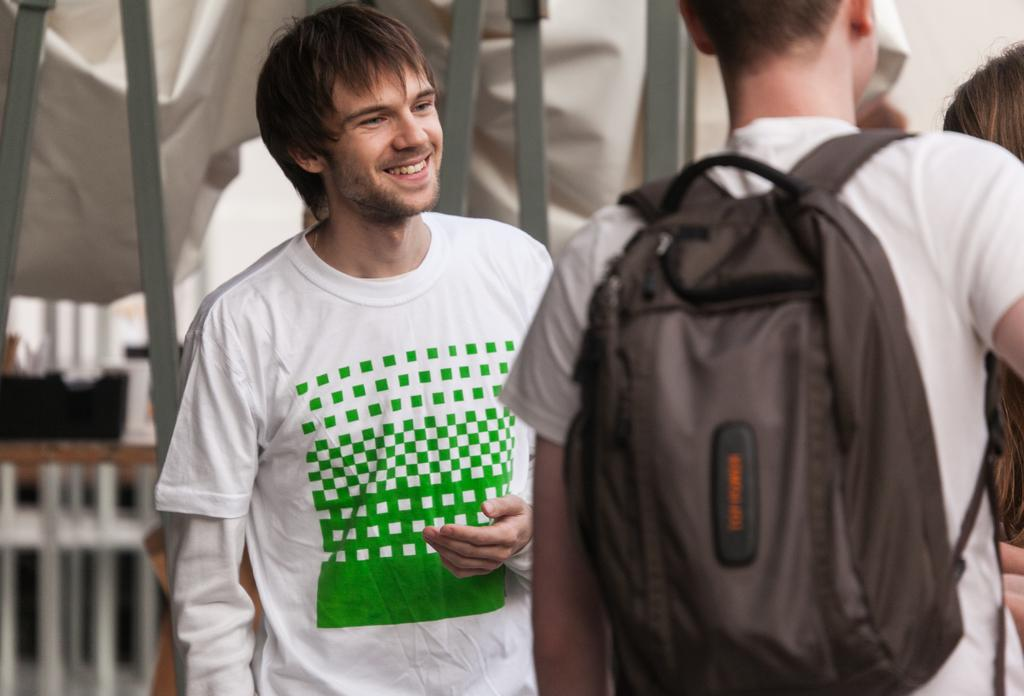How many men are present in the image? There are two men in the image. Can you describe the expressions or actions of the men? One of the men is smiling, and the other man is carrying a bag. What can be seen in the background of the image? There are rods, a fence, cloth, and people visible in the background of the image. What type of nut is being used to build the houses in the image? There are no houses present in the image, so it is not possible to determine if any nuts are being used for construction. Can you describe the insects that are crawling on the cloth in the image? There are no insects visible in the image, so it is not possible to describe any insects crawling on the cloth. 